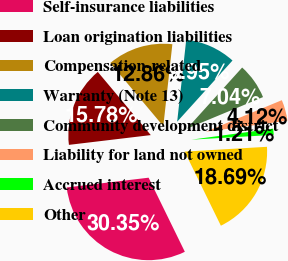Convert chart. <chart><loc_0><loc_0><loc_500><loc_500><pie_chart><fcel>Self-insurance liabilities<fcel>Loan origination liabilities<fcel>Compensation-related<fcel>Warranty (Note 13)<fcel>Community development district<fcel>Liability for land not owned<fcel>Accrued interest<fcel>Other<nl><fcel>30.35%<fcel>15.78%<fcel>12.86%<fcel>9.95%<fcel>7.04%<fcel>4.12%<fcel>1.21%<fcel>18.69%<nl></chart> 